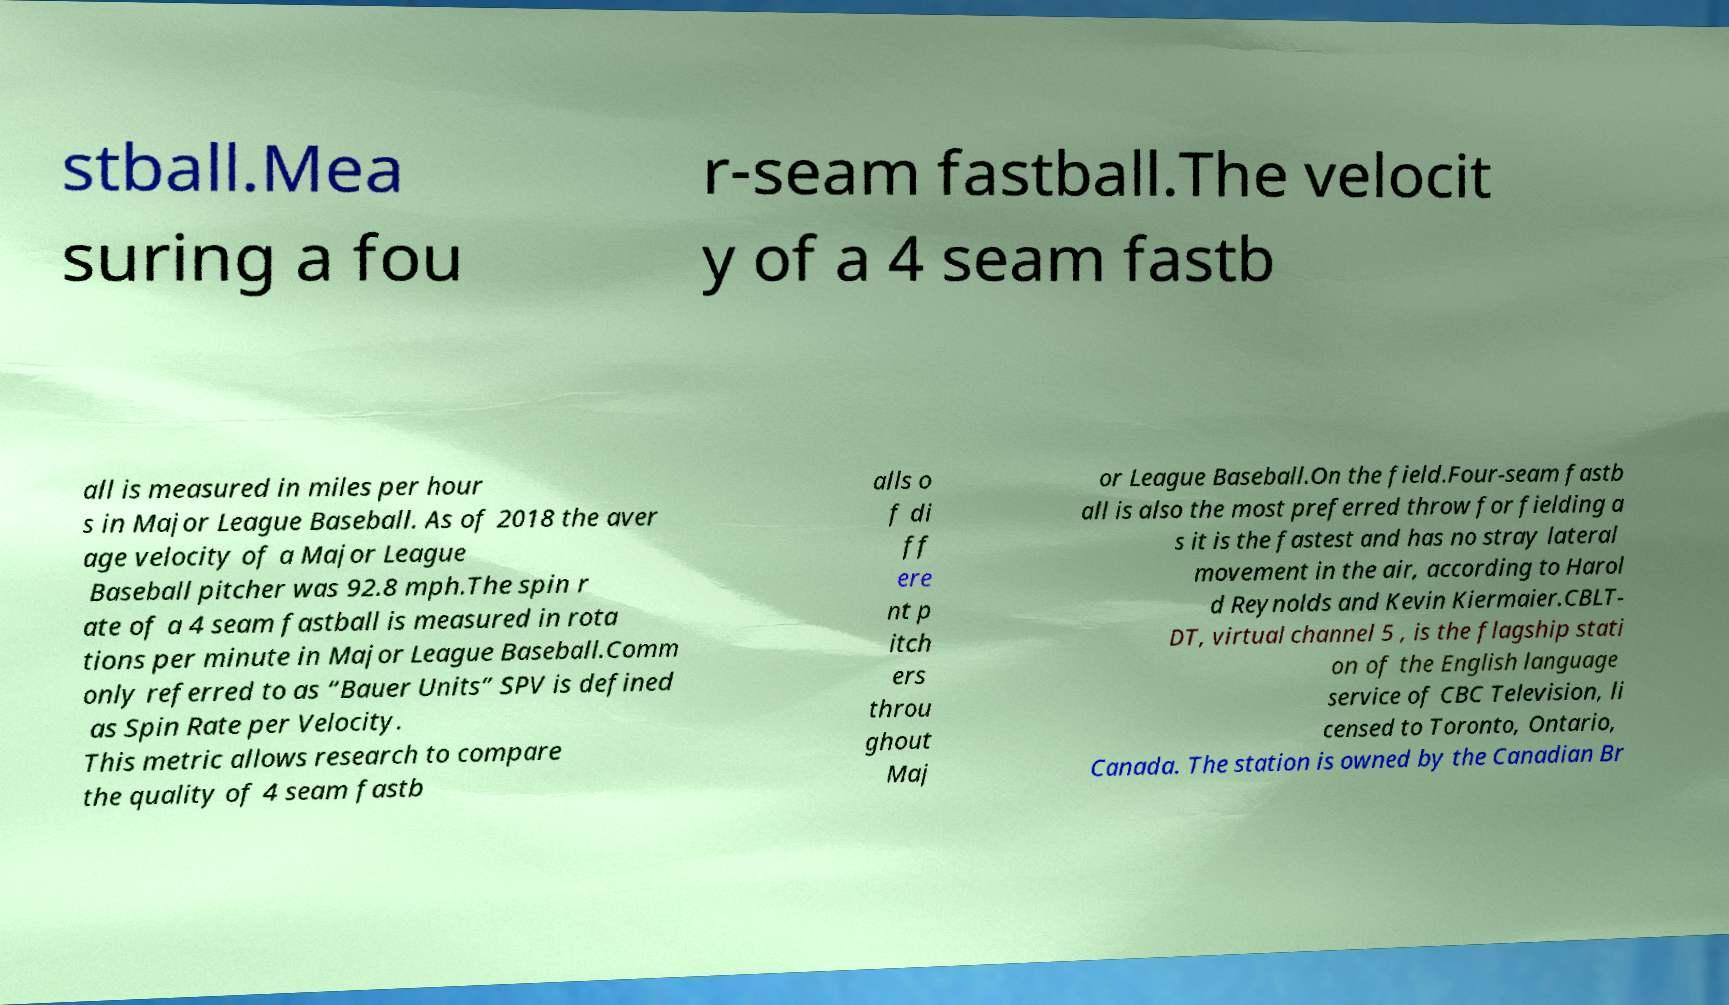For documentation purposes, I need the text within this image transcribed. Could you provide that? stball.Mea suring a fou r-seam fastball.The velocit y of a 4 seam fastb all is measured in miles per hour s in Major League Baseball. As of 2018 the aver age velocity of a Major League Baseball pitcher was 92.8 mph.The spin r ate of a 4 seam fastball is measured in rota tions per minute in Major League Baseball.Comm only referred to as “Bauer Units” SPV is defined as Spin Rate per Velocity. This metric allows research to compare the quality of 4 seam fastb alls o f di ff ere nt p itch ers throu ghout Maj or League Baseball.On the field.Four-seam fastb all is also the most preferred throw for fielding a s it is the fastest and has no stray lateral movement in the air, according to Harol d Reynolds and Kevin Kiermaier.CBLT- DT, virtual channel 5 , is the flagship stati on of the English language service of CBC Television, li censed to Toronto, Ontario, Canada. The station is owned by the Canadian Br 